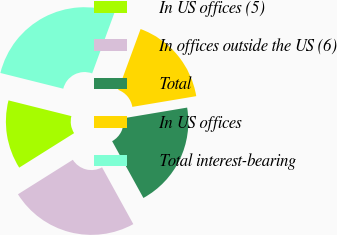Convert chart. <chart><loc_0><loc_0><loc_500><loc_500><pie_chart><fcel>In US offices (5)<fcel>In offices outside the US (6)<fcel>Total<fcel>In US offices<fcel>Total interest-bearing<nl><fcel>12.83%<fcel>24.08%<fcel>19.63%<fcel>16.75%<fcel>26.7%<nl></chart> 